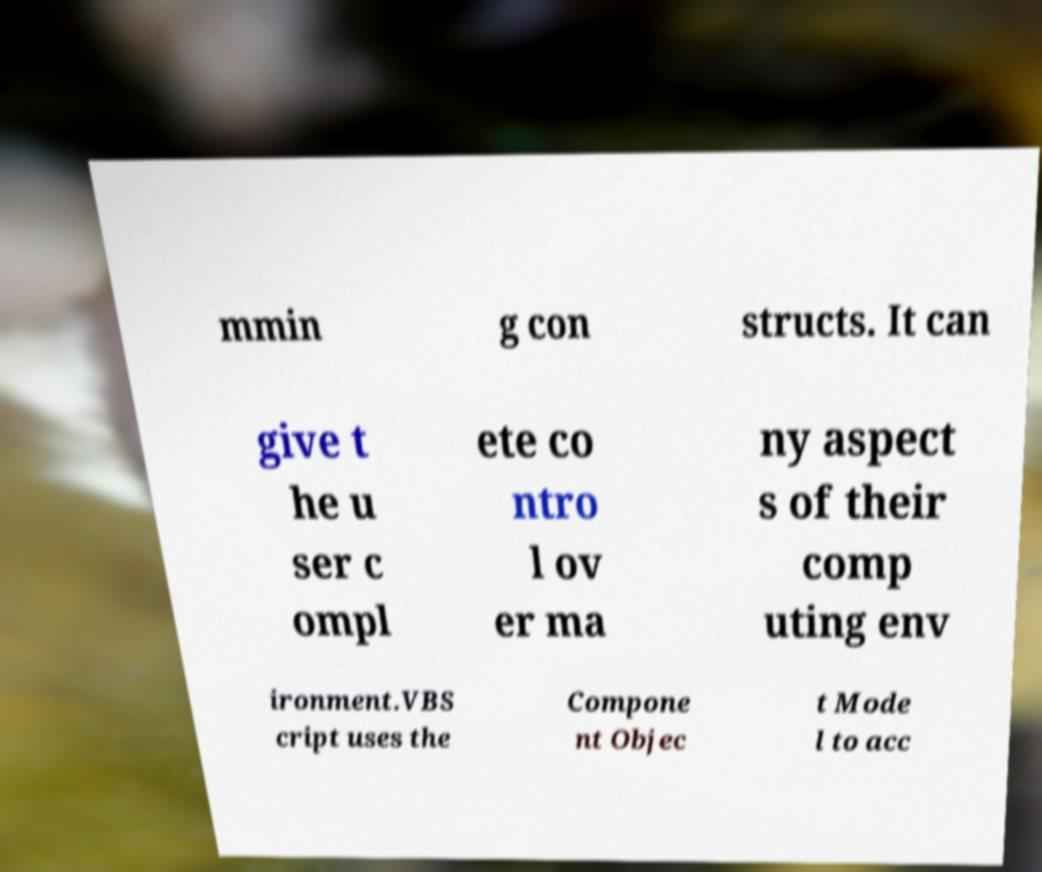Could you assist in decoding the text presented in this image and type it out clearly? mmin g con structs. It can give t he u ser c ompl ete co ntro l ov er ma ny aspect s of their comp uting env ironment.VBS cript uses the Compone nt Objec t Mode l to acc 